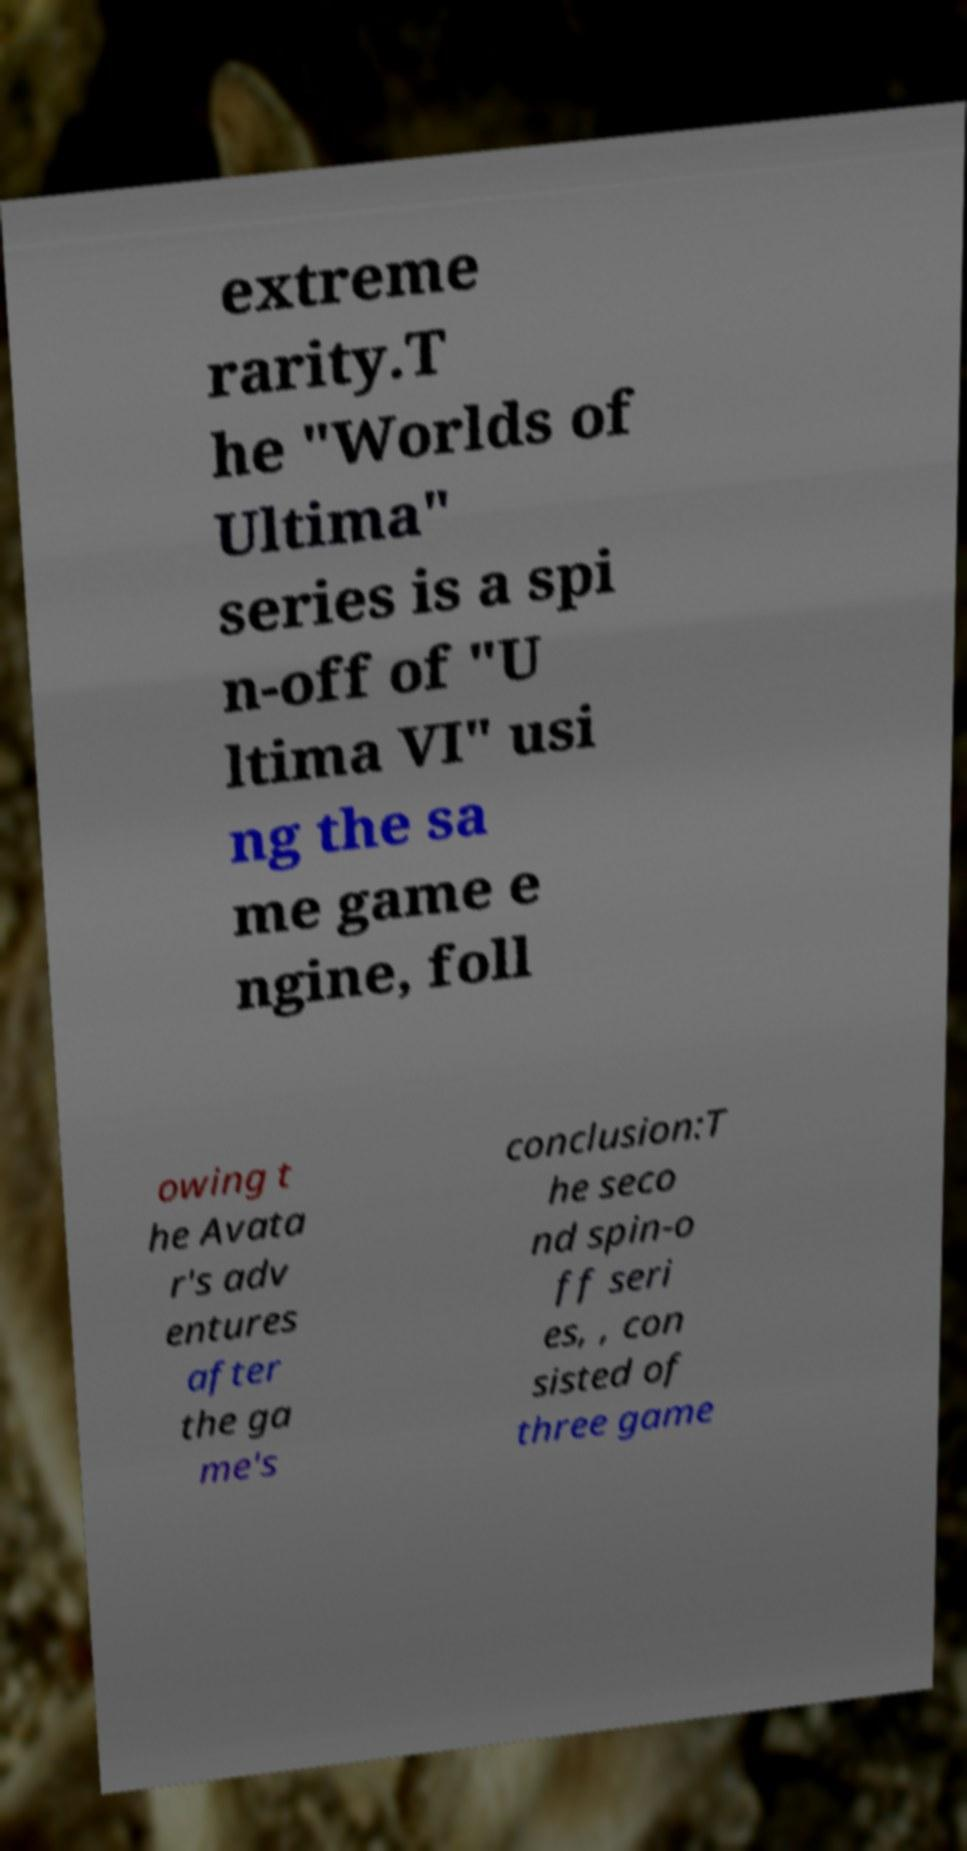There's text embedded in this image that I need extracted. Can you transcribe it verbatim? extreme rarity.T he "Worlds of Ultima" series is a spi n-off of "U ltima VI" usi ng the sa me game e ngine, foll owing t he Avata r's adv entures after the ga me's conclusion:T he seco nd spin-o ff seri es, , con sisted of three game 